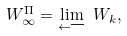<formula> <loc_0><loc_0><loc_500><loc_500>W _ { \infty } ^ { \Pi } = \underset { \longleftarrow } { \lim } \ W _ { k } ,</formula> 